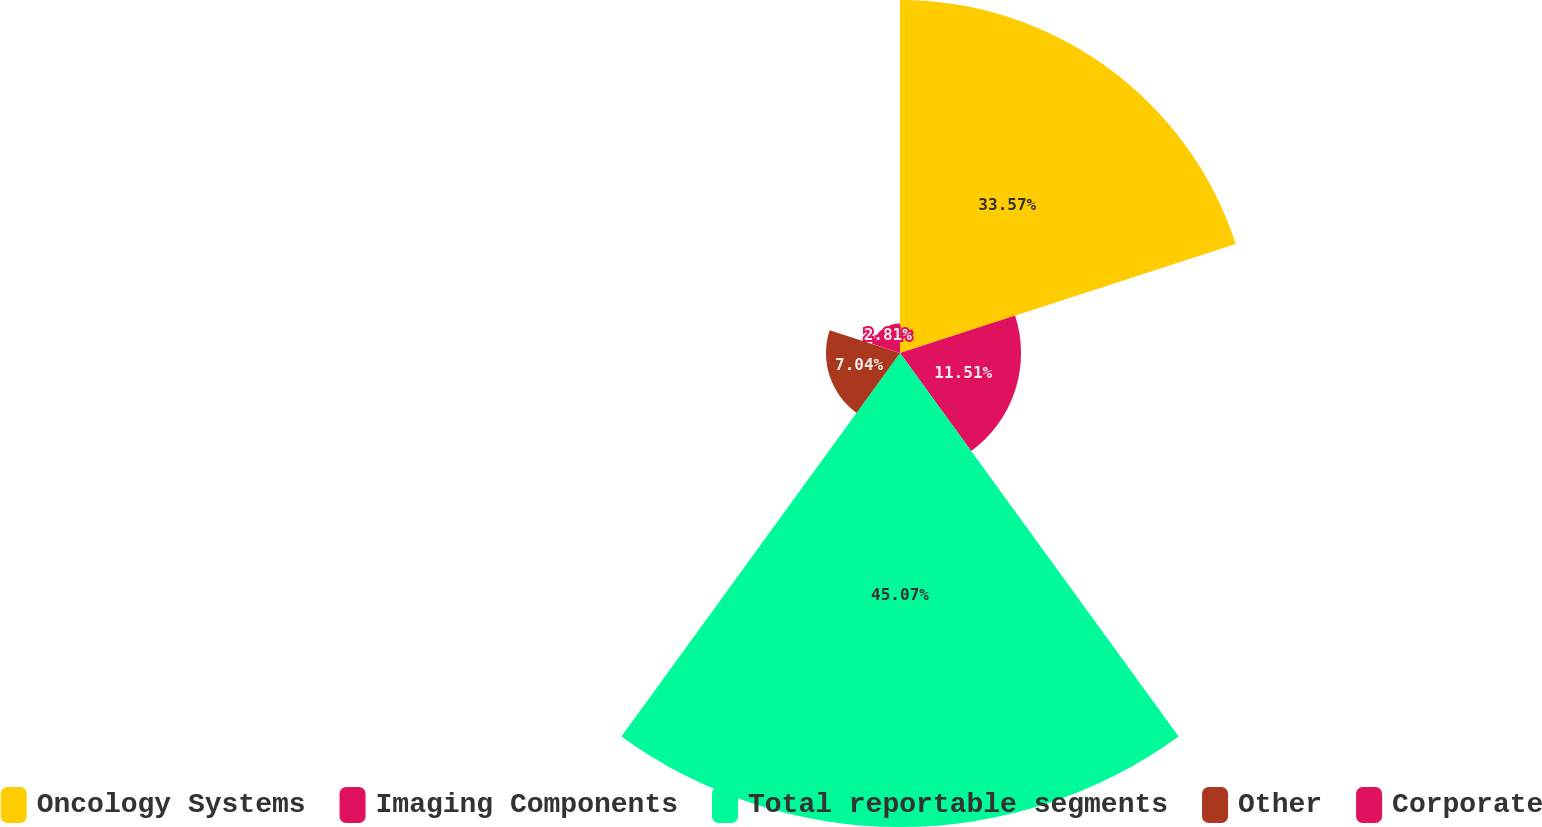<chart> <loc_0><loc_0><loc_500><loc_500><pie_chart><fcel>Oncology Systems<fcel>Imaging Components<fcel>Total reportable segments<fcel>Other<fcel>Corporate<nl><fcel>33.57%<fcel>11.51%<fcel>45.08%<fcel>7.04%<fcel>2.81%<nl></chart> 